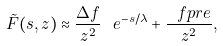<formula> <loc_0><loc_0><loc_500><loc_500>\tilde { F } ( s , z ) \approx \frac { \Delta f } { z ^ { 2 } } \ e ^ { - s / \lambda } + \frac { \ f p r e } { z ^ { 2 } } ,</formula> 